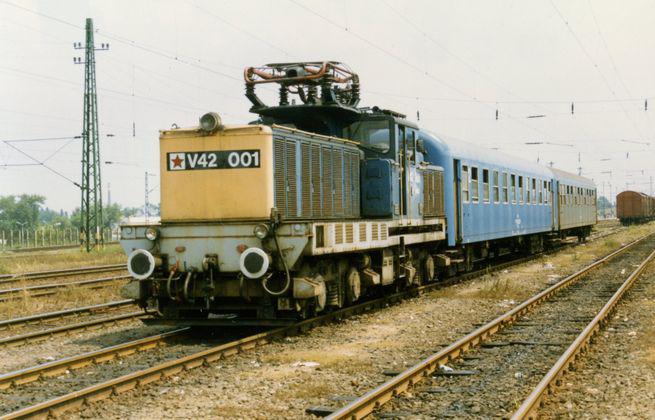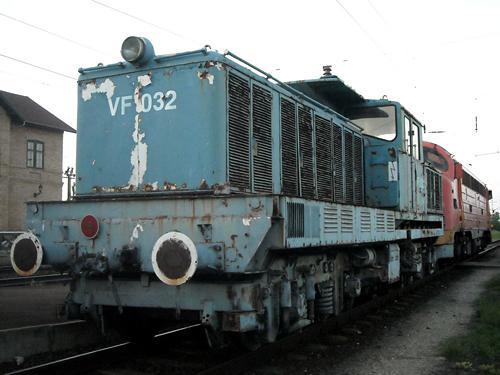The first image is the image on the left, the second image is the image on the right. For the images displayed, is the sentence "An image shows a reddish-orange train facing rightward." factually correct? Answer yes or no. No. 